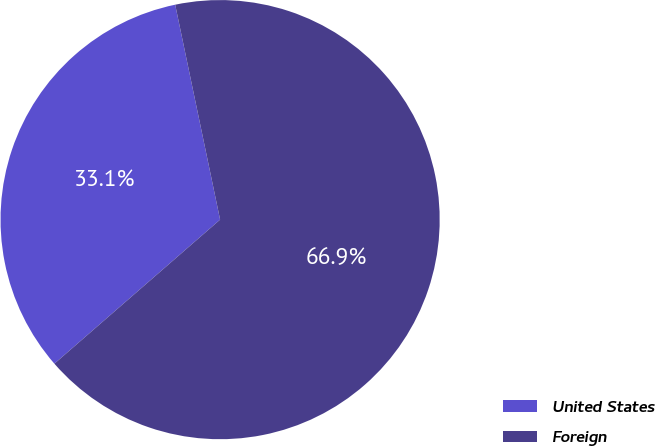Convert chart. <chart><loc_0><loc_0><loc_500><loc_500><pie_chart><fcel>United States<fcel>Foreign<nl><fcel>33.11%<fcel>66.89%<nl></chart> 